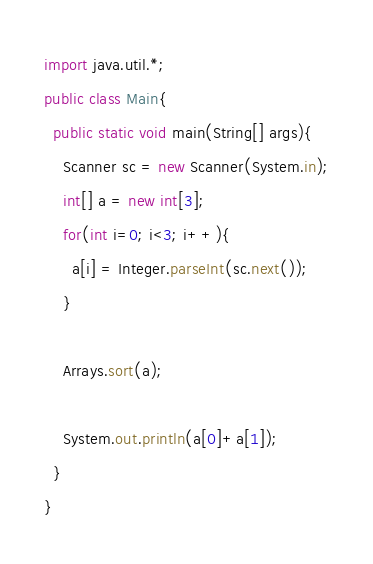<code> <loc_0><loc_0><loc_500><loc_500><_Java_>import java.util.*;
public class Main{
  public static void main(String[] args){
    Scanner sc = new Scanner(System.in);
    int[] a = new int[3];
    for(int i=0; i<3; i++){
      a[i] = Integer.parseInt(sc.next());
    }

    Arrays.sort(a);

    System.out.println(a[0]+a[1]);
  }
}</code> 